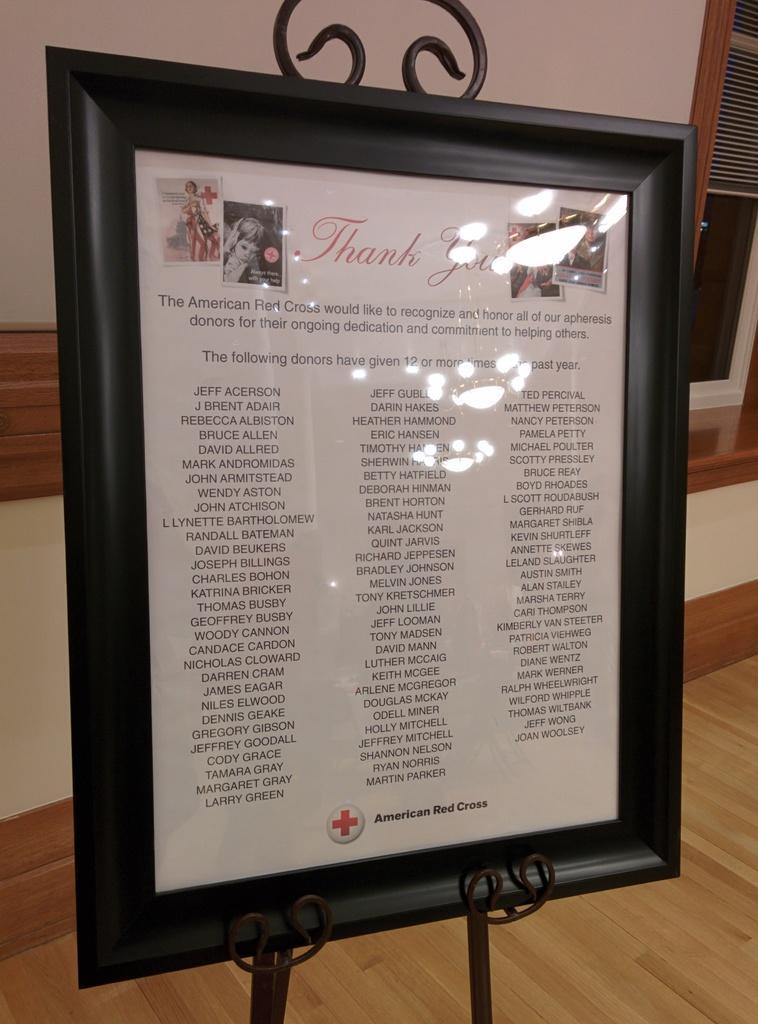Please provide a concise description of this image. Here I can see a black color frame on which I can see some text. This is attached to a metal stand and this metal stand is placed on the floor. In the background there is a wall and a window. 